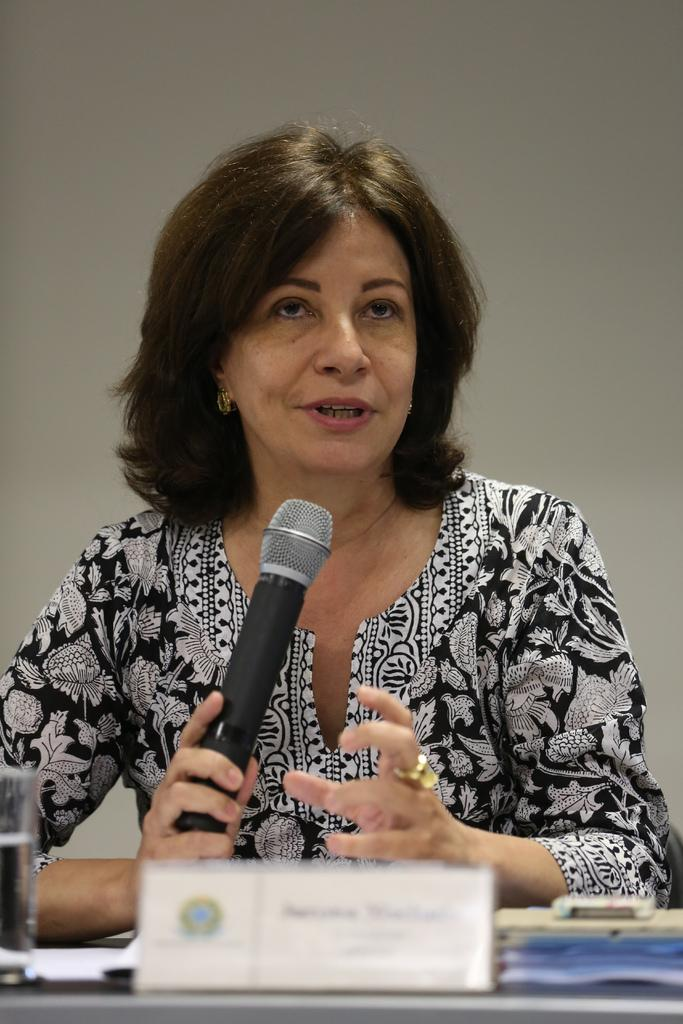Who is the main subject in the image? There is a woman in the image. What is the woman holding in the image? The woman is holding a microphone. What is located in front of the woman? There is a table in front of the woman. What objects can be seen on the table? There is a glass and a poster on the table. What type of crack can be heard in the background of the image? There is no sound or crack present in the image; it is a still image. 